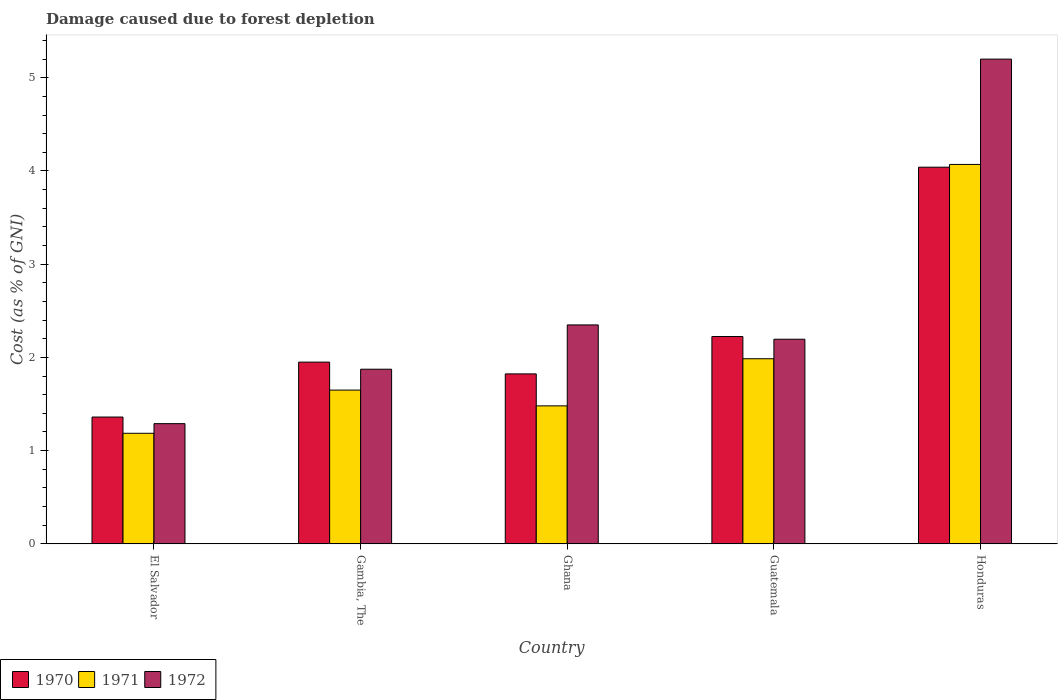How many groups of bars are there?
Give a very brief answer. 5. How many bars are there on the 5th tick from the left?
Provide a short and direct response. 3. What is the label of the 2nd group of bars from the left?
Provide a short and direct response. Gambia, The. In how many cases, is the number of bars for a given country not equal to the number of legend labels?
Provide a succinct answer. 0. What is the cost of damage caused due to forest depletion in 1972 in El Salvador?
Your answer should be compact. 1.29. Across all countries, what is the maximum cost of damage caused due to forest depletion in 1971?
Offer a terse response. 4.07. Across all countries, what is the minimum cost of damage caused due to forest depletion in 1971?
Give a very brief answer. 1.19. In which country was the cost of damage caused due to forest depletion in 1971 maximum?
Ensure brevity in your answer.  Honduras. In which country was the cost of damage caused due to forest depletion in 1970 minimum?
Your answer should be compact. El Salvador. What is the total cost of damage caused due to forest depletion in 1970 in the graph?
Give a very brief answer. 11.4. What is the difference between the cost of damage caused due to forest depletion in 1970 in Guatemala and that in Honduras?
Your answer should be compact. -1.82. What is the difference between the cost of damage caused due to forest depletion in 1971 in Ghana and the cost of damage caused due to forest depletion in 1970 in Gambia, The?
Ensure brevity in your answer.  -0.47. What is the average cost of damage caused due to forest depletion in 1972 per country?
Your response must be concise. 2.58. What is the difference between the cost of damage caused due to forest depletion of/in 1970 and cost of damage caused due to forest depletion of/in 1972 in El Salvador?
Provide a succinct answer. 0.07. In how many countries, is the cost of damage caused due to forest depletion in 1970 greater than 4.8 %?
Ensure brevity in your answer.  0. What is the ratio of the cost of damage caused due to forest depletion in 1971 in Ghana to that in Guatemala?
Keep it short and to the point. 0.75. What is the difference between the highest and the second highest cost of damage caused due to forest depletion in 1970?
Offer a terse response. -0.27. What is the difference between the highest and the lowest cost of damage caused due to forest depletion in 1970?
Your answer should be very brief. 2.68. In how many countries, is the cost of damage caused due to forest depletion in 1970 greater than the average cost of damage caused due to forest depletion in 1970 taken over all countries?
Provide a short and direct response. 1. What does the 3rd bar from the left in Gambia, The represents?
Provide a succinct answer. 1972. Are all the bars in the graph horizontal?
Offer a terse response. No. Does the graph contain grids?
Your response must be concise. No. Where does the legend appear in the graph?
Keep it short and to the point. Bottom left. How many legend labels are there?
Ensure brevity in your answer.  3. How are the legend labels stacked?
Keep it short and to the point. Horizontal. What is the title of the graph?
Provide a succinct answer. Damage caused due to forest depletion. Does "1982" appear as one of the legend labels in the graph?
Your answer should be compact. No. What is the label or title of the X-axis?
Your answer should be very brief. Country. What is the label or title of the Y-axis?
Ensure brevity in your answer.  Cost (as % of GNI). What is the Cost (as % of GNI) in 1970 in El Salvador?
Offer a very short reply. 1.36. What is the Cost (as % of GNI) of 1971 in El Salvador?
Keep it short and to the point. 1.19. What is the Cost (as % of GNI) of 1972 in El Salvador?
Ensure brevity in your answer.  1.29. What is the Cost (as % of GNI) of 1970 in Gambia, The?
Give a very brief answer. 1.95. What is the Cost (as % of GNI) in 1971 in Gambia, The?
Your answer should be very brief. 1.65. What is the Cost (as % of GNI) of 1972 in Gambia, The?
Provide a short and direct response. 1.87. What is the Cost (as % of GNI) of 1970 in Ghana?
Ensure brevity in your answer.  1.82. What is the Cost (as % of GNI) of 1971 in Ghana?
Offer a very short reply. 1.48. What is the Cost (as % of GNI) of 1972 in Ghana?
Give a very brief answer. 2.35. What is the Cost (as % of GNI) of 1970 in Guatemala?
Offer a very short reply. 2.22. What is the Cost (as % of GNI) in 1971 in Guatemala?
Offer a terse response. 1.99. What is the Cost (as % of GNI) in 1972 in Guatemala?
Keep it short and to the point. 2.19. What is the Cost (as % of GNI) in 1970 in Honduras?
Ensure brevity in your answer.  4.04. What is the Cost (as % of GNI) of 1971 in Honduras?
Your answer should be very brief. 4.07. What is the Cost (as % of GNI) of 1972 in Honduras?
Provide a succinct answer. 5.2. Across all countries, what is the maximum Cost (as % of GNI) of 1970?
Keep it short and to the point. 4.04. Across all countries, what is the maximum Cost (as % of GNI) in 1971?
Offer a terse response. 4.07. Across all countries, what is the maximum Cost (as % of GNI) of 1972?
Your answer should be compact. 5.2. Across all countries, what is the minimum Cost (as % of GNI) of 1970?
Offer a very short reply. 1.36. Across all countries, what is the minimum Cost (as % of GNI) of 1971?
Your response must be concise. 1.19. Across all countries, what is the minimum Cost (as % of GNI) in 1972?
Your answer should be very brief. 1.29. What is the total Cost (as % of GNI) of 1970 in the graph?
Provide a short and direct response. 11.4. What is the total Cost (as % of GNI) in 1971 in the graph?
Make the answer very short. 10.37. What is the total Cost (as % of GNI) in 1972 in the graph?
Keep it short and to the point. 12.91. What is the difference between the Cost (as % of GNI) of 1970 in El Salvador and that in Gambia, The?
Keep it short and to the point. -0.59. What is the difference between the Cost (as % of GNI) of 1971 in El Salvador and that in Gambia, The?
Provide a succinct answer. -0.46. What is the difference between the Cost (as % of GNI) in 1972 in El Salvador and that in Gambia, The?
Provide a succinct answer. -0.58. What is the difference between the Cost (as % of GNI) in 1970 in El Salvador and that in Ghana?
Make the answer very short. -0.46. What is the difference between the Cost (as % of GNI) in 1971 in El Salvador and that in Ghana?
Provide a succinct answer. -0.29. What is the difference between the Cost (as % of GNI) of 1972 in El Salvador and that in Ghana?
Ensure brevity in your answer.  -1.06. What is the difference between the Cost (as % of GNI) of 1970 in El Salvador and that in Guatemala?
Offer a terse response. -0.86. What is the difference between the Cost (as % of GNI) in 1971 in El Salvador and that in Guatemala?
Give a very brief answer. -0.8. What is the difference between the Cost (as % of GNI) of 1972 in El Salvador and that in Guatemala?
Ensure brevity in your answer.  -0.91. What is the difference between the Cost (as % of GNI) of 1970 in El Salvador and that in Honduras?
Ensure brevity in your answer.  -2.68. What is the difference between the Cost (as % of GNI) of 1971 in El Salvador and that in Honduras?
Ensure brevity in your answer.  -2.88. What is the difference between the Cost (as % of GNI) of 1972 in El Salvador and that in Honduras?
Your answer should be compact. -3.91. What is the difference between the Cost (as % of GNI) in 1970 in Gambia, The and that in Ghana?
Your answer should be compact. 0.13. What is the difference between the Cost (as % of GNI) in 1971 in Gambia, The and that in Ghana?
Provide a succinct answer. 0.17. What is the difference between the Cost (as % of GNI) of 1972 in Gambia, The and that in Ghana?
Your answer should be very brief. -0.48. What is the difference between the Cost (as % of GNI) of 1970 in Gambia, The and that in Guatemala?
Offer a very short reply. -0.27. What is the difference between the Cost (as % of GNI) of 1971 in Gambia, The and that in Guatemala?
Offer a terse response. -0.34. What is the difference between the Cost (as % of GNI) of 1972 in Gambia, The and that in Guatemala?
Your answer should be compact. -0.32. What is the difference between the Cost (as % of GNI) in 1970 in Gambia, The and that in Honduras?
Offer a terse response. -2.09. What is the difference between the Cost (as % of GNI) of 1971 in Gambia, The and that in Honduras?
Offer a terse response. -2.42. What is the difference between the Cost (as % of GNI) in 1972 in Gambia, The and that in Honduras?
Your response must be concise. -3.33. What is the difference between the Cost (as % of GNI) of 1970 in Ghana and that in Guatemala?
Offer a terse response. -0.4. What is the difference between the Cost (as % of GNI) of 1971 in Ghana and that in Guatemala?
Offer a terse response. -0.51. What is the difference between the Cost (as % of GNI) in 1972 in Ghana and that in Guatemala?
Offer a terse response. 0.15. What is the difference between the Cost (as % of GNI) in 1970 in Ghana and that in Honduras?
Give a very brief answer. -2.22. What is the difference between the Cost (as % of GNI) in 1971 in Ghana and that in Honduras?
Offer a terse response. -2.59. What is the difference between the Cost (as % of GNI) in 1972 in Ghana and that in Honduras?
Keep it short and to the point. -2.85. What is the difference between the Cost (as % of GNI) of 1970 in Guatemala and that in Honduras?
Make the answer very short. -1.82. What is the difference between the Cost (as % of GNI) of 1971 in Guatemala and that in Honduras?
Your answer should be very brief. -2.08. What is the difference between the Cost (as % of GNI) of 1972 in Guatemala and that in Honduras?
Offer a very short reply. -3. What is the difference between the Cost (as % of GNI) of 1970 in El Salvador and the Cost (as % of GNI) of 1971 in Gambia, The?
Provide a succinct answer. -0.29. What is the difference between the Cost (as % of GNI) in 1970 in El Salvador and the Cost (as % of GNI) in 1972 in Gambia, The?
Provide a succinct answer. -0.51. What is the difference between the Cost (as % of GNI) in 1971 in El Salvador and the Cost (as % of GNI) in 1972 in Gambia, The?
Your response must be concise. -0.69. What is the difference between the Cost (as % of GNI) in 1970 in El Salvador and the Cost (as % of GNI) in 1971 in Ghana?
Your answer should be very brief. -0.12. What is the difference between the Cost (as % of GNI) in 1970 in El Salvador and the Cost (as % of GNI) in 1972 in Ghana?
Your response must be concise. -0.99. What is the difference between the Cost (as % of GNI) in 1971 in El Salvador and the Cost (as % of GNI) in 1972 in Ghana?
Your answer should be very brief. -1.16. What is the difference between the Cost (as % of GNI) in 1970 in El Salvador and the Cost (as % of GNI) in 1971 in Guatemala?
Your response must be concise. -0.63. What is the difference between the Cost (as % of GNI) in 1970 in El Salvador and the Cost (as % of GNI) in 1972 in Guatemala?
Offer a terse response. -0.83. What is the difference between the Cost (as % of GNI) of 1971 in El Salvador and the Cost (as % of GNI) of 1972 in Guatemala?
Keep it short and to the point. -1.01. What is the difference between the Cost (as % of GNI) in 1970 in El Salvador and the Cost (as % of GNI) in 1971 in Honduras?
Your answer should be compact. -2.71. What is the difference between the Cost (as % of GNI) of 1970 in El Salvador and the Cost (as % of GNI) of 1972 in Honduras?
Give a very brief answer. -3.84. What is the difference between the Cost (as % of GNI) in 1971 in El Salvador and the Cost (as % of GNI) in 1972 in Honduras?
Your answer should be compact. -4.01. What is the difference between the Cost (as % of GNI) in 1970 in Gambia, The and the Cost (as % of GNI) in 1971 in Ghana?
Provide a short and direct response. 0.47. What is the difference between the Cost (as % of GNI) of 1970 in Gambia, The and the Cost (as % of GNI) of 1972 in Ghana?
Your response must be concise. -0.4. What is the difference between the Cost (as % of GNI) in 1971 in Gambia, The and the Cost (as % of GNI) in 1972 in Ghana?
Your response must be concise. -0.7. What is the difference between the Cost (as % of GNI) of 1970 in Gambia, The and the Cost (as % of GNI) of 1971 in Guatemala?
Ensure brevity in your answer.  -0.04. What is the difference between the Cost (as % of GNI) in 1970 in Gambia, The and the Cost (as % of GNI) in 1972 in Guatemala?
Ensure brevity in your answer.  -0.25. What is the difference between the Cost (as % of GNI) in 1971 in Gambia, The and the Cost (as % of GNI) in 1972 in Guatemala?
Keep it short and to the point. -0.55. What is the difference between the Cost (as % of GNI) in 1970 in Gambia, The and the Cost (as % of GNI) in 1971 in Honduras?
Offer a very short reply. -2.12. What is the difference between the Cost (as % of GNI) of 1970 in Gambia, The and the Cost (as % of GNI) of 1972 in Honduras?
Your answer should be very brief. -3.25. What is the difference between the Cost (as % of GNI) in 1971 in Gambia, The and the Cost (as % of GNI) in 1972 in Honduras?
Your answer should be very brief. -3.55. What is the difference between the Cost (as % of GNI) of 1970 in Ghana and the Cost (as % of GNI) of 1971 in Guatemala?
Your answer should be compact. -0.16. What is the difference between the Cost (as % of GNI) in 1970 in Ghana and the Cost (as % of GNI) in 1972 in Guatemala?
Make the answer very short. -0.37. What is the difference between the Cost (as % of GNI) in 1971 in Ghana and the Cost (as % of GNI) in 1972 in Guatemala?
Offer a terse response. -0.71. What is the difference between the Cost (as % of GNI) of 1970 in Ghana and the Cost (as % of GNI) of 1971 in Honduras?
Your response must be concise. -2.25. What is the difference between the Cost (as % of GNI) of 1970 in Ghana and the Cost (as % of GNI) of 1972 in Honduras?
Ensure brevity in your answer.  -3.38. What is the difference between the Cost (as % of GNI) of 1971 in Ghana and the Cost (as % of GNI) of 1972 in Honduras?
Provide a short and direct response. -3.72. What is the difference between the Cost (as % of GNI) in 1970 in Guatemala and the Cost (as % of GNI) in 1971 in Honduras?
Ensure brevity in your answer.  -1.85. What is the difference between the Cost (as % of GNI) in 1970 in Guatemala and the Cost (as % of GNI) in 1972 in Honduras?
Offer a terse response. -2.98. What is the difference between the Cost (as % of GNI) of 1971 in Guatemala and the Cost (as % of GNI) of 1972 in Honduras?
Provide a short and direct response. -3.21. What is the average Cost (as % of GNI) in 1970 per country?
Ensure brevity in your answer.  2.28. What is the average Cost (as % of GNI) in 1971 per country?
Provide a short and direct response. 2.07. What is the average Cost (as % of GNI) of 1972 per country?
Your response must be concise. 2.58. What is the difference between the Cost (as % of GNI) of 1970 and Cost (as % of GNI) of 1971 in El Salvador?
Make the answer very short. 0.17. What is the difference between the Cost (as % of GNI) of 1970 and Cost (as % of GNI) of 1972 in El Salvador?
Provide a succinct answer. 0.07. What is the difference between the Cost (as % of GNI) of 1971 and Cost (as % of GNI) of 1972 in El Salvador?
Your answer should be compact. -0.1. What is the difference between the Cost (as % of GNI) of 1970 and Cost (as % of GNI) of 1972 in Gambia, The?
Make the answer very short. 0.08. What is the difference between the Cost (as % of GNI) in 1971 and Cost (as % of GNI) in 1972 in Gambia, The?
Provide a short and direct response. -0.22. What is the difference between the Cost (as % of GNI) in 1970 and Cost (as % of GNI) in 1971 in Ghana?
Make the answer very short. 0.34. What is the difference between the Cost (as % of GNI) of 1970 and Cost (as % of GNI) of 1972 in Ghana?
Your response must be concise. -0.53. What is the difference between the Cost (as % of GNI) in 1971 and Cost (as % of GNI) in 1972 in Ghana?
Your response must be concise. -0.87. What is the difference between the Cost (as % of GNI) in 1970 and Cost (as % of GNI) in 1971 in Guatemala?
Your answer should be very brief. 0.24. What is the difference between the Cost (as % of GNI) of 1970 and Cost (as % of GNI) of 1972 in Guatemala?
Make the answer very short. 0.03. What is the difference between the Cost (as % of GNI) of 1971 and Cost (as % of GNI) of 1972 in Guatemala?
Keep it short and to the point. -0.21. What is the difference between the Cost (as % of GNI) in 1970 and Cost (as % of GNI) in 1971 in Honduras?
Ensure brevity in your answer.  -0.03. What is the difference between the Cost (as % of GNI) of 1970 and Cost (as % of GNI) of 1972 in Honduras?
Make the answer very short. -1.16. What is the difference between the Cost (as % of GNI) in 1971 and Cost (as % of GNI) in 1972 in Honduras?
Offer a terse response. -1.13. What is the ratio of the Cost (as % of GNI) of 1970 in El Salvador to that in Gambia, The?
Provide a short and direct response. 0.7. What is the ratio of the Cost (as % of GNI) in 1971 in El Salvador to that in Gambia, The?
Provide a succinct answer. 0.72. What is the ratio of the Cost (as % of GNI) in 1972 in El Salvador to that in Gambia, The?
Offer a terse response. 0.69. What is the ratio of the Cost (as % of GNI) of 1970 in El Salvador to that in Ghana?
Provide a short and direct response. 0.75. What is the ratio of the Cost (as % of GNI) in 1971 in El Salvador to that in Ghana?
Your response must be concise. 0.8. What is the ratio of the Cost (as % of GNI) of 1972 in El Salvador to that in Ghana?
Offer a very short reply. 0.55. What is the ratio of the Cost (as % of GNI) in 1970 in El Salvador to that in Guatemala?
Make the answer very short. 0.61. What is the ratio of the Cost (as % of GNI) in 1971 in El Salvador to that in Guatemala?
Offer a very short reply. 0.6. What is the ratio of the Cost (as % of GNI) of 1972 in El Salvador to that in Guatemala?
Ensure brevity in your answer.  0.59. What is the ratio of the Cost (as % of GNI) of 1970 in El Salvador to that in Honduras?
Keep it short and to the point. 0.34. What is the ratio of the Cost (as % of GNI) in 1971 in El Salvador to that in Honduras?
Provide a short and direct response. 0.29. What is the ratio of the Cost (as % of GNI) of 1972 in El Salvador to that in Honduras?
Offer a terse response. 0.25. What is the ratio of the Cost (as % of GNI) in 1970 in Gambia, The to that in Ghana?
Give a very brief answer. 1.07. What is the ratio of the Cost (as % of GNI) in 1971 in Gambia, The to that in Ghana?
Provide a succinct answer. 1.11. What is the ratio of the Cost (as % of GNI) in 1972 in Gambia, The to that in Ghana?
Provide a succinct answer. 0.8. What is the ratio of the Cost (as % of GNI) of 1970 in Gambia, The to that in Guatemala?
Your answer should be compact. 0.88. What is the ratio of the Cost (as % of GNI) in 1971 in Gambia, The to that in Guatemala?
Provide a succinct answer. 0.83. What is the ratio of the Cost (as % of GNI) in 1972 in Gambia, The to that in Guatemala?
Offer a very short reply. 0.85. What is the ratio of the Cost (as % of GNI) of 1970 in Gambia, The to that in Honduras?
Your response must be concise. 0.48. What is the ratio of the Cost (as % of GNI) in 1971 in Gambia, The to that in Honduras?
Your answer should be very brief. 0.41. What is the ratio of the Cost (as % of GNI) in 1972 in Gambia, The to that in Honduras?
Your answer should be very brief. 0.36. What is the ratio of the Cost (as % of GNI) of 1970 in Ghana to that in Guatemala?
Give a very brief answer. 0.82. What is the ratio of the Cost (as % of GNI) of 1971 in Ghana to that in Guatemala?
Give a very brief answer. 0.75. What is the ratio of the Cost (as % of GNI) in 1972 in Ghana to that in Guatemala?
Give a very brief answer. 1.07. What is the ratio of the Cost (as % of GNI) in 1970 in Ghana to that in Honduras?
Offer a very short reply. 0.45. What is the ratio of the Cost (as % of GNI) in 1971 in Ghana to that in Honduras?
Your response must be concise. 0.36. What is the ratio of the Cost (as % of GNI) in 1972 in Ghana to that in Honduras?
Provide a short and direct response. 0.45. What is the ratio of the Cost (as % of GNI) in 1970 in Guatemala to that in Honduras?
Your response must be concise. 0.55. What is the ratio of the Cost (as % of GNI) in 1971 in Guatemala to that in Honduras?
Provide a short and direct response. 0.49. What is the ratio of the Cost (as % of GNI) in 1972 in Guatemala to that in Honduras?
Your response must be concise. 0.42. What is the difference between the highest and the second highest Cost (as % of GNI) of 1970?
Keep it short and to the point. 1.82. What is the difference between the highest and the second highest Cost (as % of GNI) in 1971?
Ensure brevity in your answer.  2.08. What is the difference between the highest and the second highest Cost (as % of GNI) in 1972?
Ensure brevity in your answer.  2.85. What is the difference between the highest and the lowest Cost (as % of GNI) in 1970?
Offer a very short reply. 2.68. What is the difference between the highest and the lowest Cost (as % of GNI) of 1971?
Provide a succinct answer. 2.88. What is the difference between the highest and the lowest Cost (as % of GNI) of 1972?
Provide a short and direct response. 3.91. 